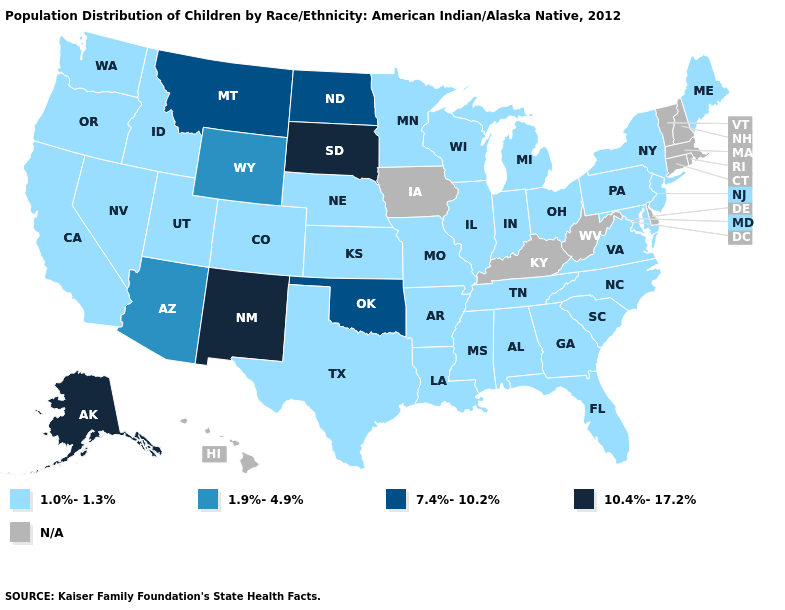Which states have the lowest value in the MidWest?
Keep it brief. Illinois, Indiana, Kansas, Michigan, Minnesota, Missouri, Nebraska, Ohio, Wisconsin. Is the legend a continuous bar?
Concise answer only. No. Does the map have missing data?
Write a very short answer. Yes. What is the lowest value in states that border Arkansas?
Write a very short answer. 1.0%-1.3%. What is the highest value in states that border Kentucky?
Concise answer only. 1.0%-1.3%. Which states have the lowest value in the USA?
Short answer required. Alabama, Arkansas, California, Colorado, Florida, Georgia, Idaho, Illinois, Indiana, Kansas, Louisiana, Maine, Maryland, Michigan, Minnesota, Mississippi, Missouri, Nebraska, Nevada, New Jersey, New York, North Carolina, Ohio, Oregon, Pennsylvania, South Carolina, Tennessee, Texas, Utah, Virginia, Washington, Wisconsin. What is the value of New Mexico?
Be succinct. 10.4%-17.2%. Is the legend a continuous bar?
Keep it brief. No. Does South Dakota have the highest value in the USA?
Quick response, please. Yes. What is the value of Rhode Island?
Write a very short answer. N/A. What is the value of Michigan?
Concise answer only. 1.0%-1.3%. What is the value of Indiana?
Keep it brief. 1.0%-1.3%. 